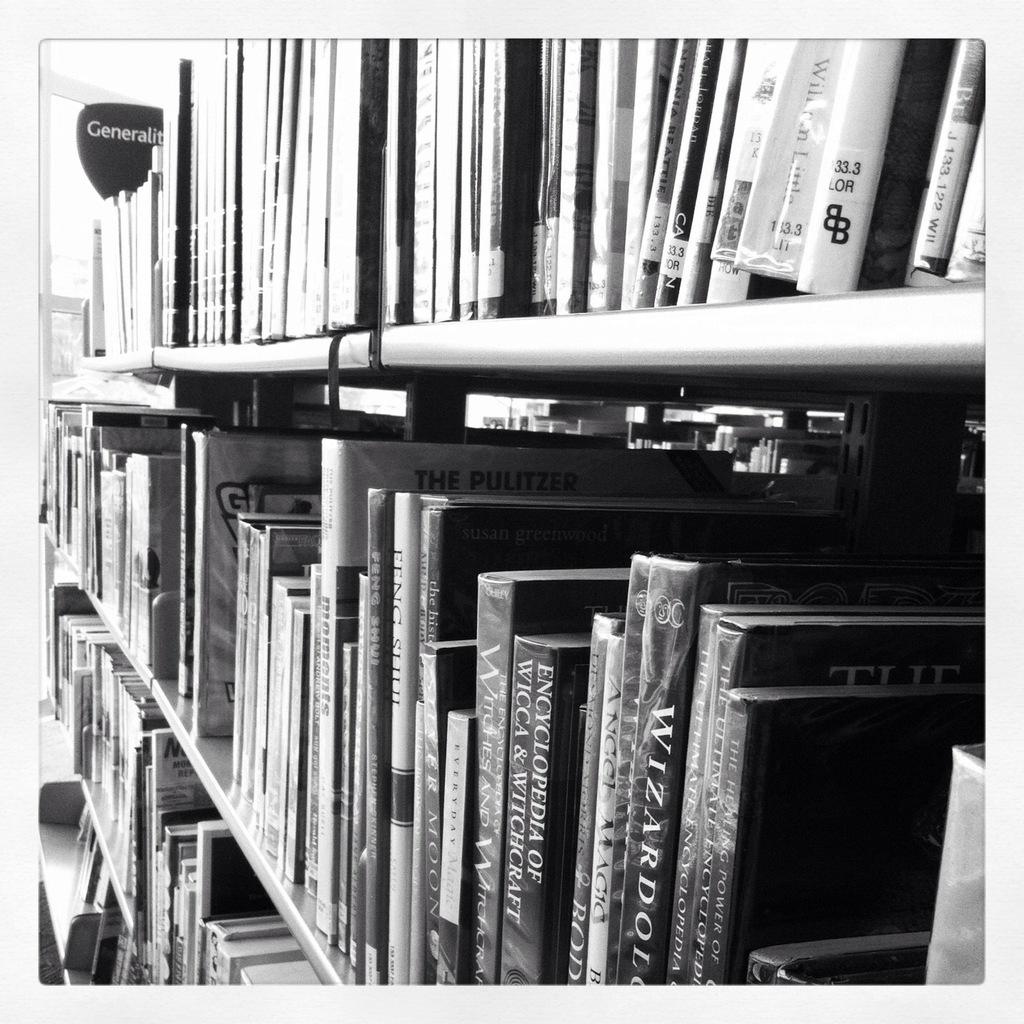<image>
Provide a brief description of the given image. A generalities section of books on shelves including wizardry and witchcraft topics. 